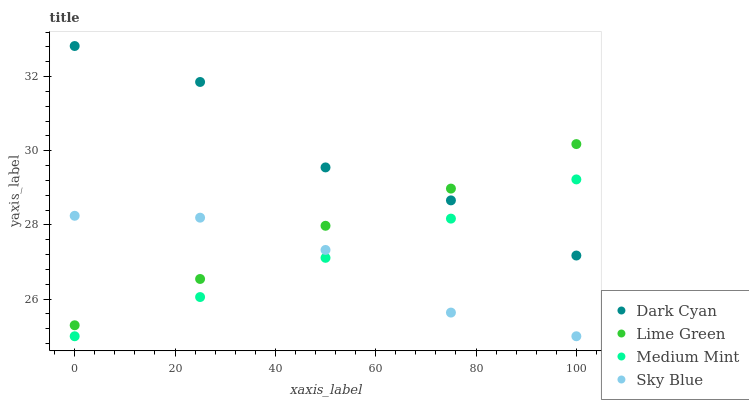Does Sky Blue have the minimum area under the curve?
Answer yes or no. Yes. Does Dark Cyan have the maximum area under the curve?
Answer yes or no. Yes. Does Medium Mint have the minimum area under the curve?
Answer yes or no. No. Does Medium Mint have the maximum area under the curve?
Answer yes or no. No. Is Medium Mint the smoothest?
Answer yes or no. Yes. Is Dark Cyan the roughest?
Answer yes or no. Yes. Is Lime Green the smoothest?
Answer yes or no. No. Is Lime Green the roughest?
Answer yes or no. No. Does Medium Mint have the lowest value?
Answer yes or no. Yes. Does Lime Green have the lowest value?
Answer yes or no. No. Does Dark Cyan have the highest value?
Answer yes or no. Yes. Does Medium Mint have the highest value?
Answer yes or no. No. Is Sky Blue less than Dark Cyan?
Answer yes or no. Yes. Is Dark Cyan greater than Sky Blue?
Answer yes or no. Yes. Does Medium Mint intersect Sky Blue?
Answer yes or no. Yes. Is Medium Mint less than Sky Blue?
Answer yes or no. No. Is Medium Mint greater than Sky Blue?
Answer yes or no. No. Does Sky Blue intersect Dark Cyan?
Answer yes or no. No. 